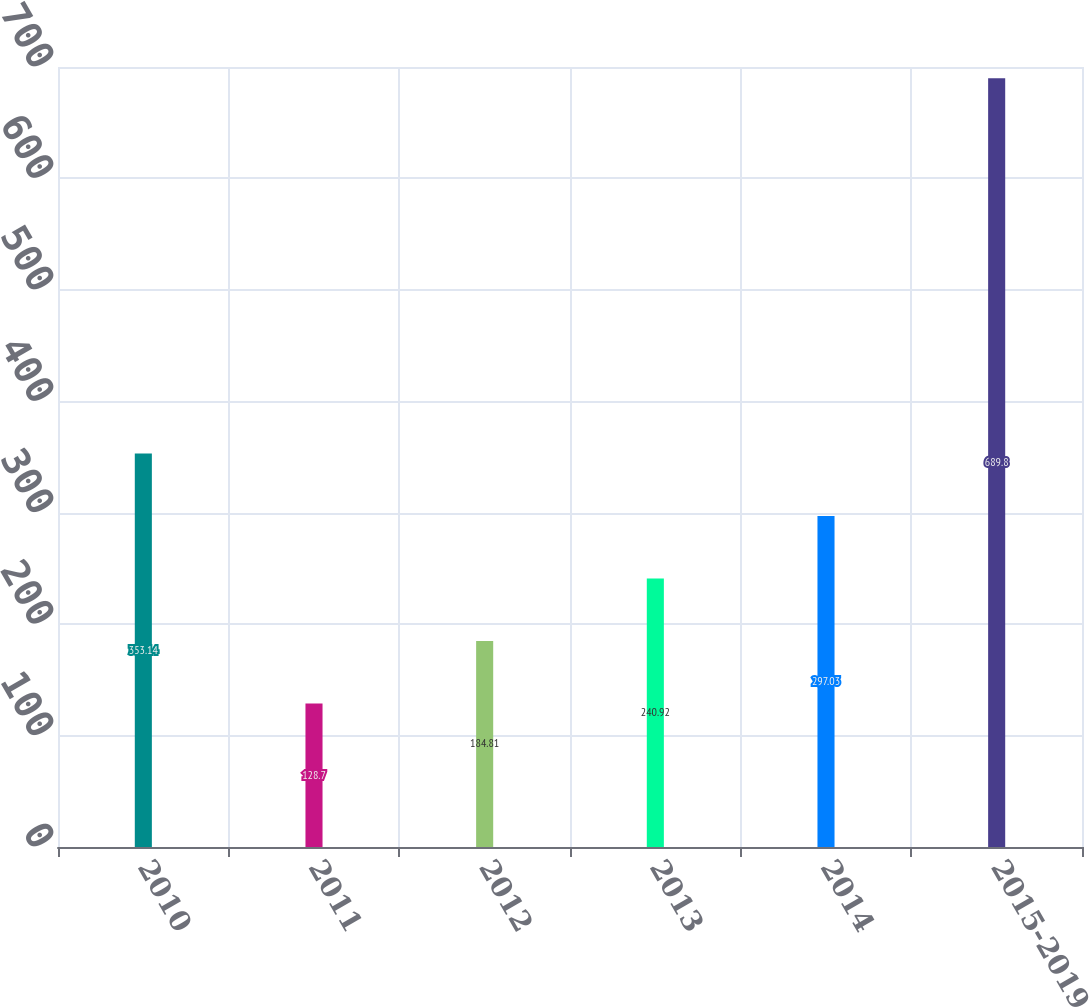Convert chart to OTSL. <chart><loc_0><loc_0><loc_500><loc_500><bar_chart><fcel>2010<fcel>2011<fcel>2012<fcel>2013<fcel>2014<fcel>2015-2019<nl><fcel>353.14<fcel>128.7<fcel>184.81<fcel>240.92<fcel>297.03<fcel>689.8<nl></chart> 